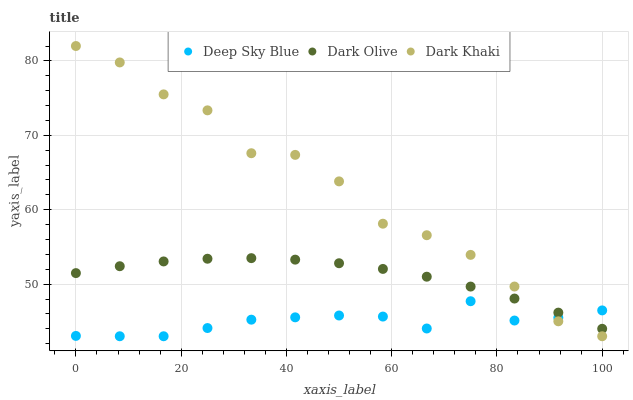Does Deep Sky Blue have the minimum area under the curve?
Answer yes or no. Yes. Does Dark Khaki have the maximum area under the curve?
Answer yes or no. Yes. Does Dark Olive have the minimum area under the curve?
Answer yes or no. No. Does Dark Olive have the maximum area under the curve?
Answer yes or no. No. Is Dark Olive the smoothest?
Answer yes or no. Yes. Is Dark Khaki the roughest?
Answer yes or no. Yes. Is Deep Sky Blue the smoothest?
Answer yes or no. No. Is Deep Sky Blue the roughest?
Answer yes or no. No. Does Dark Khaki have the lowest value?
Answer yes or no. Yes. Does Dark Olive have the lowest value?
Answer yes or no. No. Does Dark Khaki have the highest value?
Answer yes or no. Yes. Does Dark Olive have the highest value?
Answer yes or no. No. Does Dark Olive intersect Deep Sky Blue?
Answer yes or no. Yes. Is Dark Olive less than Deep Sky Blue?
Answer yes or no. No. Is Dark Olive greater than Deep Sky Blue?
Answer yes or no. No. 